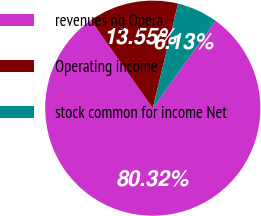Convert chart to OTSL. <chart><loc_0><loc_0><loc_500><loc_500><pie_chart><fcel>revenues ng Opera<fcel>Operating income<fcel>stock common for income Net<nl><fcel>80.31%<fcel>13.55%<fcel>6.13%<nl></chart> 